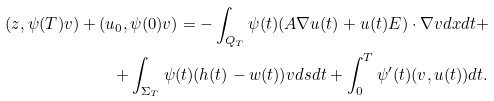Convert formula to latex. <formula><loc_0><loc_0><loc_500><loc_500>( z , \psi ( T ) v ) + ( u _ { 0 } , \psi ( 0 ) v ) = - \int _ { Q _ { T } } \psi ( t ) ( A \nabla u ( t ) + u ( t ) { E } ) \cdot \nabla v d x d t + \\ + \int _ { \Sigma _ { T } } \psi ( t ) ( h ( t ) - w ( t ) ) v d s d t + \int _ { 0 } ^ { T } \psi ^ { \prime } ( t ) ( v , u ( t ) ) d t .</formula> 